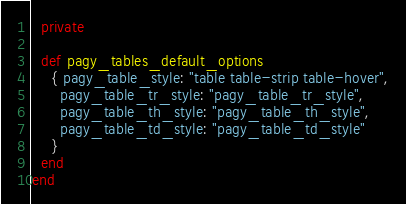Convert code to text. <code><loc_0><loc_0><loc_500><loc_500><_Ruby_>
  private

  def pagy_tables_default_options
    { pagy_table_style: "table table-strip table-hover",
      pagy_table_tr_style: "pagy_table_tr_style",
      pagy_table_th_style: "pagy_table_th_style",
      pagy_table_td_style: "pagy_table_td_style"
    }
  end
end</code> 